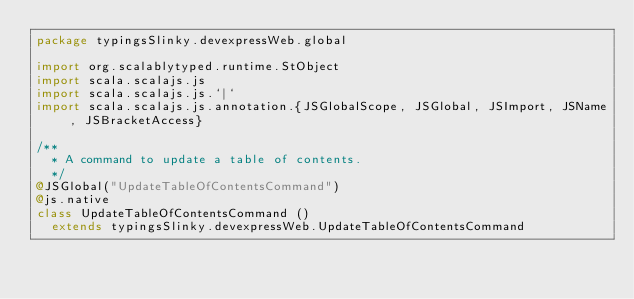Convert code to text. <code><loc_0><loc_0><loc_500><loc_500><_Scala_>package typingsSlinky.devexpressWeb.global

import org.scalablytyped.runtime.StObject
import scala.scalajs.js
import scala.scalajs.js.`|`
import scala.scalajs.js.annotation.{JSGlobalScope, JSGlobal, JSImport, JSName, JSBracketAccess}

/**
  * A command to update a table of contents.
  */
@JSGlobal("UpdateTableOfContentsCommand")
@js.native
class UpdateTableOfContentsCommand ()
  extends typingsSlinky.devexpressWeb.UpdateTableOfContentsCommand
</code> 